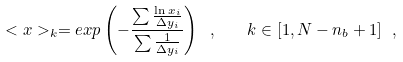<formula> <loc_0><loc_0><loc_500><loc_500>< x > _ { k } = e x p \left ( - \frac { \sum \frac { \ln x _ { i } } { \Delta y _ { i } } } { \sum \frac { 1 } { \Delta y _ { i } } } \right ) \ , \quad k \in { [ 1 , N - n _ { b } + 1 ] } \ ,</formula> 